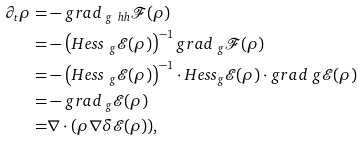<formula> <loc_0><loc_0><loc_500><loc_500>\partial _ { t } \rho = & - g r a d _ { \ g ^ { \ } h h } \mathcal { F } ( \rho ) \\ = & - \left ( H e s s _ { \ g } \mathcal { E } ( \rho ) \right ) ^ { - 1 } g r a d _ { \ g } \mathcal { F } ( \rho ) \\ = & - \left ( H e s s _ { \ g } \mathcal { E } ( \rho ) \right ) ^ { - 1 } \cdot H e s s _ { g } \mathcal { E } ( \rho ) \cdot g r a d _ { \ } g \mathcal { E } ( \rho ) \\ = & - g r a d _ { \ g } \mathcal { E } ( \rho ) \\ = & \nabla \cdot ( \rho \nabla \delta \mathcal { E } ( \rho ) ) ,</formula> 